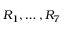Convert formula to latex. <formula><loc_0><loc_0><loc_500><loc_500>R _ { 1 } , \dots , R _ { 7 }</formula> 